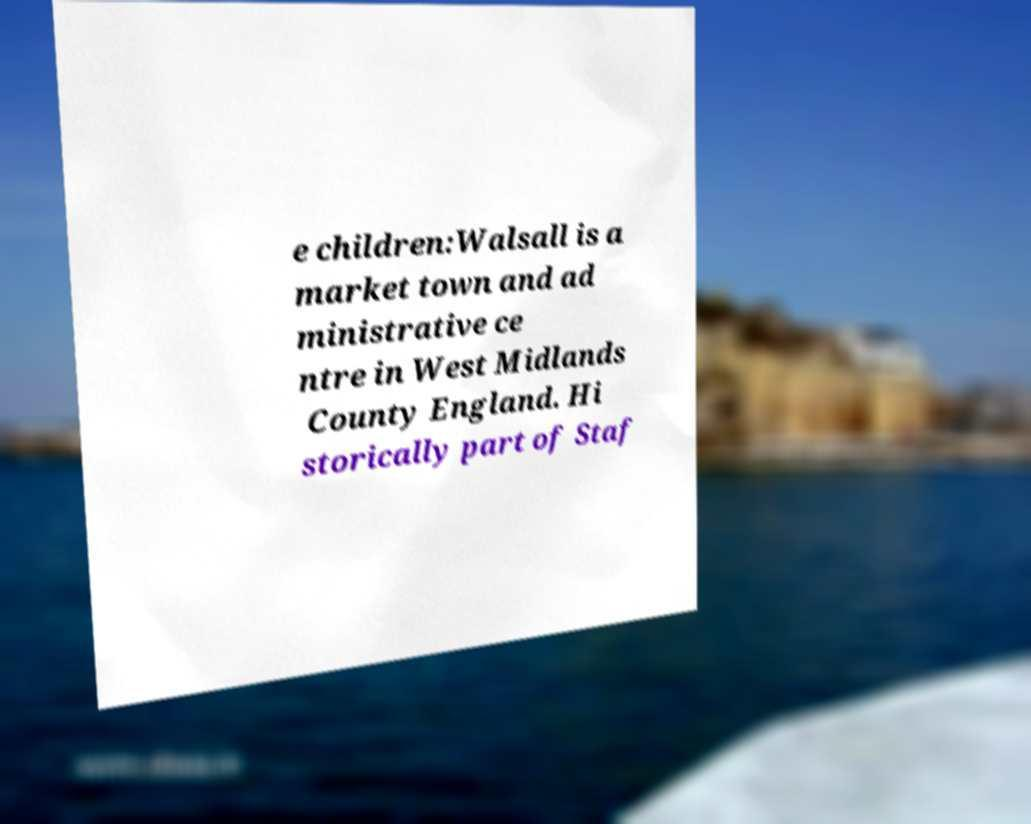There's text embedded in this image that I need extracted. Can you transcribe it verbatim? e children:Walsall is a market town and ad ministrative ce ntre in West Midlands County England. Hi storically part of Staf 